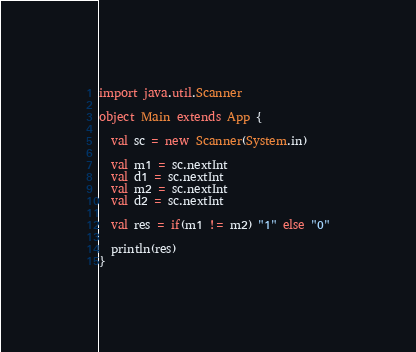Convert code to text. <code><loc_0><loc_0><loc_500><loc_500><_Scala_>import java.util.Scanner

object Main extends App {

  val sc = new Scanner(System.in)

  val m1 = sc.nextInt
  val d1 = sc.nextInt
  val m2 = sc.nextInt
  val d2 = sc.nextInt

  val res = if(m1 != m2) "1" else "0"

  println(res)
}</code> 